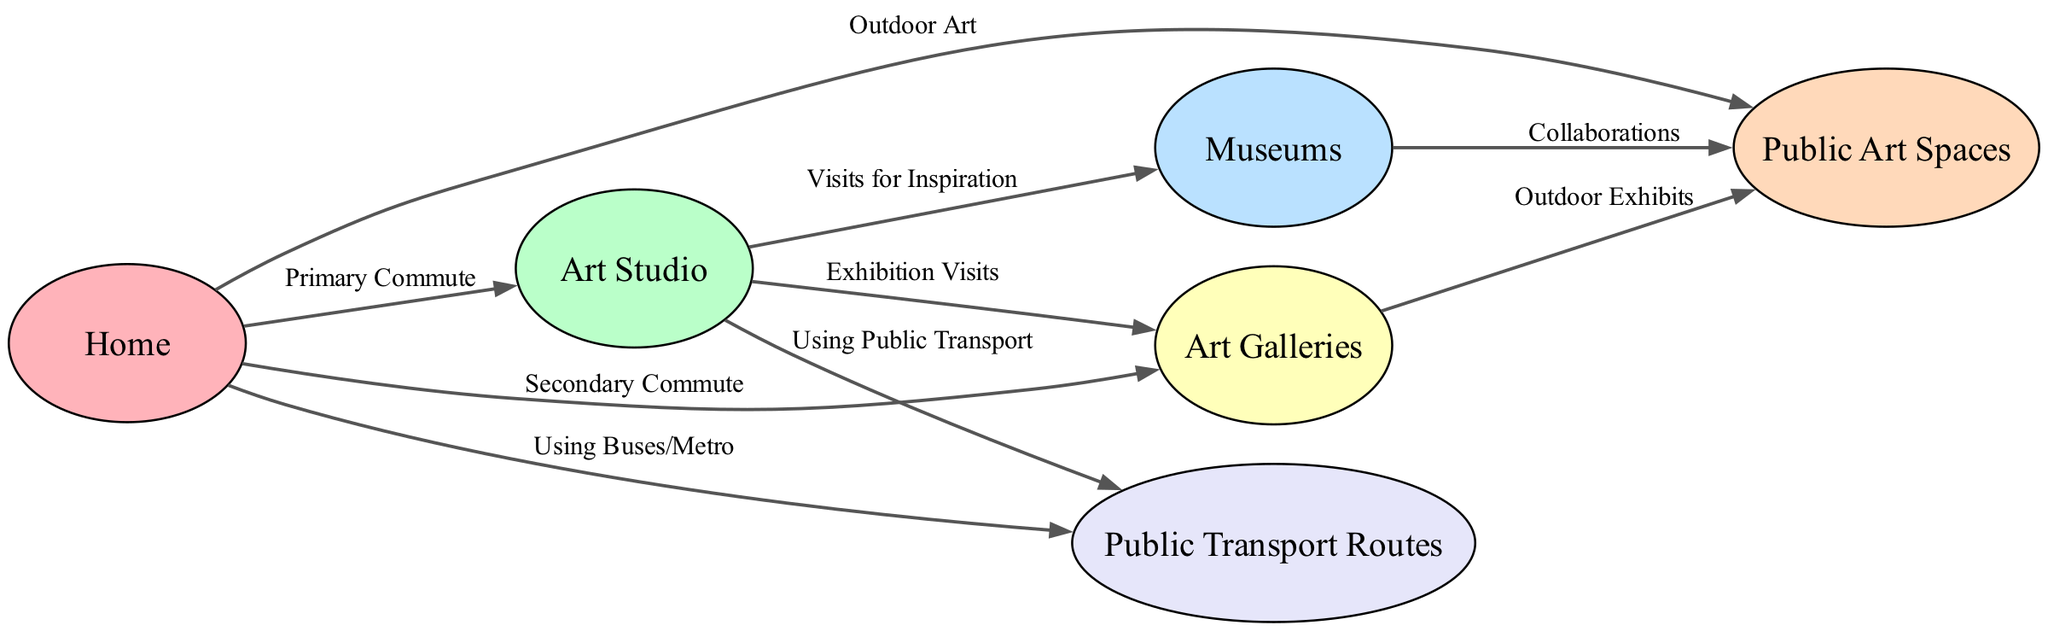What is the primary location from home? The diagram indicates that the primary commute from home is to the studio. This is shown by the directed edge from the "home" node to the "studio" node labeled "Primary Commute."
Answer: studio How many nodes are in the diagram? By counting the unique locations depicted in the diagram, it is clear that there are six nodes: home, art studio, museums, galleries, public art spaces, and public transport routes.
Answer: 6 Which locations are connected to the studio? The studio is connected to three locations: museums (for inspiration), galleries (for exhibition visits), and transport routes (using public transport), as indicated by the edges extending from the studio.
Answer: museums, galleries, transport routes What type of visits does the studio have to galleries? The diagram specifies that the relationship between the studio and galleries is an "Exhibition Visits" edge. This indicates that the studio specifically engages in visiting galleries for exhibitions.
Answer: Exhibition Visits How do artists primarily commute from their home for outdoor art experiences? The diagram shows an edge from home to public spaces with the label "Outdoor Art," indicating that artists primarily commute from their home to public spaces for outdoor art experiences.
Answer: Outdoor Art What is the secondary commute from home? The diagram indicates that the secondary commute from home is to galleries, which is represented by the edge labeled "Secondary Commute" linking "home" to "galleries."
Answer: galleries From which locations do artists use public transport? The diagram indicates that artists use public transportation from both home and studio, as shown by the edges labeled "Using Buses/Metro" from home and "Using Public Transport" from the studio.
Answer: home, studio What collaborative link exists between museums and public spaces? The diagram establishes a connection between museums and public spaces through an edge labeled "Collaborations," indicating joint activities or partnerships between these two locations.
Answer: Collaborations Which edge describes the relationship between galleries and public spaces? The relationship between galleries and public spaces is described by the edge labeled "Outdoor Exhibits," which indicates the type of activities that artists engage in between these two locations.
Answer: Outdoor Exhibits 